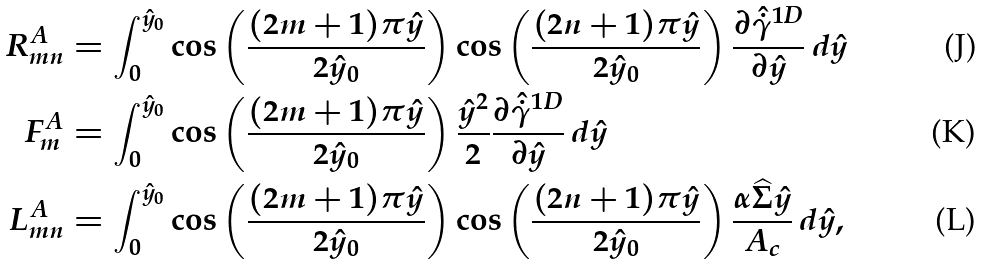Convert formula to latex. <formula><loc_0><loc_0><loc_500><loc_500>R _ { m n } ^ { A } & = \int _ { 0 } ^ { \hat { y } _ { 0 } } \cos \left ( \frac { ( 2 m + 1 ) \pi \hat { y } } { 2 \hat { y } _ { 0 } } \right ) \cos \left ( \frac { ( 2 n + 1 ) \pi \hat { y } } { 2 \hat { y } _ { 0 } } \right ) \frac { \partial \hat { \dot { \gamma } } ^ { 1 D } } { \partial \hat { y } } \, d \hat { y } \\ F ^ { A } _ { m } & = \int _ { 0 } ^ { \hat { y } _ { 0 } } \cos \left ( \frac { ( 2 m + 1 ) \pi \hat { y } } { 2 \hat { y } _ { 0 } } \right ) \frac { \hat { y } ^ { 2 } } { 2 } \frac { \partial \hat { \dot { \gamma } } ^ { 1 D } } { \partial \hat { y } } \, d \hat { y } \\ L _ { m n } ^ { A } & = \int _ { 0 } ^ { \hat { y } _ { 0 } } \cos \left ( \frac { ( 2 m + 1 ) \pi \hat { y } } { 2 \hat { y } _ { 0 } } \right ) \cos \left ( \frac { ( 2 n + 1 ) \pi \hat { y } } { 2 \hat { y } _ { 0 } } \right ) \frac { \alpha \widehat { \Sigma } \hat { y } } { A _ { c } } \, d \hat { y } ,</formula> 